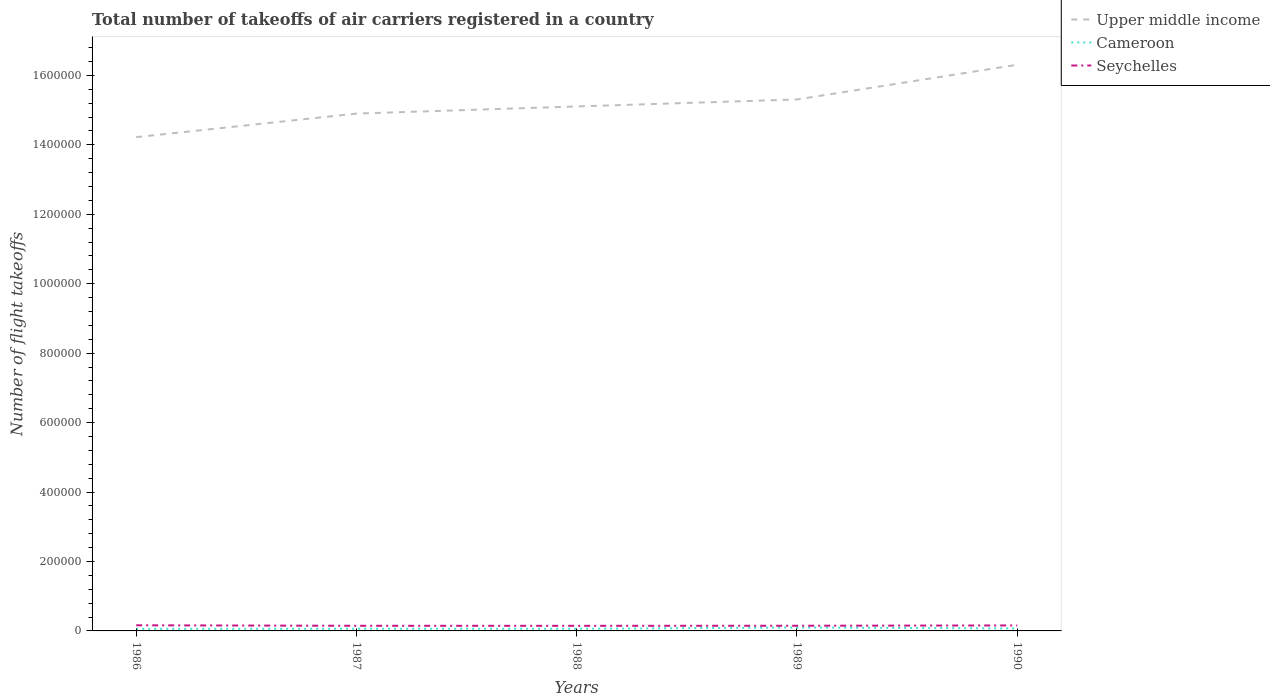How many different coloured lines are there?
Give a very brief answer. 3. Does the line corresponding to Seychelles intersect with the line corresponding to Cameroon?
Give a very brief answer. No. Across all years, what is the maximum total number of flight takeoffs in Seychelles?
Offer a terse response. 1.47e+04. In which year was the total number of flight takeoffs in Cameroon maximum?
Provide a short and direct response. 1986. What is the total total number of flight takeoffs in Upper middle income in the graph?
Provide a short and direct response. -2.06e+04. What is the difference between the highest and the second highest total number of flight takeoffs in Seychelles?
Provide a succinct answer. 1500. Is the total number of flight takeoffs in Upper middle income strictly greater than the total number of flight takeoffs in Seychelles over the years?
Ensure brevity in your answer.  No. What is the difference between two consecutive major ticks on the Y-axis?
Your answer should be very brief. 2.00e+05. Does the graph contain any zero values?
Provide a succinct answer. No. Where does the legend appear in the graph?
Offer a terse response. Top right. What is the title of the graph?
Your answer should be very brief. Total number of takeoffs of air carriers registered in a country. What is the label or title of the X-axis?
Provide a short and direct response. Years. What is the label or title of the Y-axis?
Make the answer very short. Number of flight takeoffs. What is the Number of flight takeoffs of Upper middle income in 1986?
Keep it short and to the point. 1.42e+06. What is the Number of flight takeoffs in Cameroon in 1986?
Keep it short and to the point. 6100. What is the Number of flight takeoffs of Seychelles in 1986?
Your answer should be very brief. 1.62e+04. What is the Number of flight takeoffs in Upper middle income in 1987?
Provide a succinct answer. 1.49e+06. What is the Number of flight takeoffs of Cameroon in 1987?
Give a very brief answer. 6200. What is the Number of flight takeoffs in Seychelles in 1987?
Provide a succinct answer. 1.48e+04. What is the Number of flight takeoffs in Upper middle income in 1988?
Provide a short and direct response. 1.51e+06. What is the Number of flight takeoffs in Cameroon in 1988?
Provide a short and direct response. 6200. What is the Number of flight takeoffs in Seychelles in 1988?
Your answer should be compact. 1.47e+04. What is the Number of flight takeoffs in Upper middle income in 1989?
Give a very brief answer. 1.53e+06. What is the Number of flight takeoffs of Cameroon in 1989?
Provide a short and direct response. 9700. What is the Number of flight takeoffs of Seychelles in 1989?
Ensure brevity in your answer.  1.49e+04. What is the Number of flight takeoffs in Upper middle income in 1990?
Give a very brief answer. 1.63e+06. What is the Number of flight takeoffs in Cameroon in 1990?
Give a very brief answer. 7100. What is the Number of flight takeoffs in Seychelles in 1990?
Your response must be concise. 1.58e+04. Across all years, what is the maximum Number of flight takeoffs of Upper middle income?
Your response must be concise. 1.63e+06. Across all years, what is the maximum Number of flight takeoffs in Cameroon?
Ensure brevity in your answer.  9700. Across all years, what is the maximum Number of flight takeoffs of Seychelles?
Your answer should be very brief. 1.62e+04. Across all years, what is the minimum Number of flight takeoffs of Upper middle income?
Provide a succinct answer. 1.42e+06. Across all years, what is the minimum Number of flight takeoffs of Cameroon?
Offer a terse response. 6100. Across all years, what is the minimum Number of flight takeoffs of Seychelles?
Ensure brevity in your answer.  1.47e+04. What is the total Number of flight takeoffs of Upper middle income in the graph?
Provide a short and direct response. 7.58e+06. What is the total Number of flight takeoffs in Cameroon in the graph?
Your response must be concise. 3.53e+04. What is the total Number of flight takeoffs of Seychelles in the graph?
Make the answer very short. 7.64e+04. What is the difference between the Number of flight takeoffs in Upper middle income in 1986 and that in 1987?
Keep it short and to the point. -6.78e+04. What is the difference between the Number of flight takeoffs in Cameroon in 1986 and that in 1987?
Your answer should be very brief. -100. What is the difference between the Number of flight takeoffs of Seychelles in 1986 and that in 1987?
Keep it short and to the point. 1400. What is the difference between the Number of flight takeoffs in Upper middle income in 1986 and that in 1988?
Give a very brief answer. -8.84e+04. What is the difference between the Number of flight takeoffs of Cameroon in 1986 and that in 1988?
Your response must be concise. -100. What is the difference between the Number of flight takeoffs in Seychelles in 1986 and that in 1988?
Provide a short and direct response. 1500. What is the difference between the Number of flight takeoffs of Upper middle income in 1986 and that in 1989?
Make the answer very short. -1.08e+05. What is the difference between the Number of flight takeoffs of Cameroon in 1986 and that in 1989?
Your answer should be compact. -3600. What is the difference between the Number of flight takeoffs in Seychelles in 1986 and that in 1989?
Your answer should be compact. 1300. What is the difference between the Number of flight takeoffs in Upper middle income in 1986 and that in 1990?
Offer a terse response. -2.08e+05. What is the difference between the Number of flight takeoffs of Cameroon in 1986 and that in 1990?
Keep it short and to the point. -1000. What is the difference between the Number of flight takeoffs of Upper middle income in 1987 and that in 1988?
Ensure brevity in your answer.  -2.06e+04. What is the difference between the Number of flight takeoffs of Cameroon in 1987 and that in 1988?
Your answer should be very brief. 0. What is the difference between the Number of flight takeoffs in Upper middle income in 1987 and that in 1989?
Provide a succinct answer. -4.07e+04. What is the difference between the Number of flight takeoffs of Cameroon in 1987 and that in 1989?
Make the answer very short. -3500. What is the difference between the Number of flight takeoffs of Seychelles in 1987 and that in 1989?
Your answer should be compact. -100. What is the difference between the Number of flight takeoffs in Upper middle income in 1987 and that in 1990?
Your response must be concise. -1.41e+05. What is the difference between the Number of flight takeoffs in Cameroon in 1987 and that in 1990?
Give a very brief answer. -900. What is the difference between the Number of flight takeoffs in Seychelles in 1987 and that in 1990?
Offer a terse response. -1000. What is the difference between the Number of flight takeoffs of Upper middle income in 1988 and that in 1989?
Make the answer very short. -2.01e+04. What is the difference between the Number of flight takeoffs in Cameroon in 1988 and that in 1989?
Provide a succinct answer. -3500. What is the difference between the Number of flight takeoffs of Seychelles in 1988 and that in 1989?
Keep it short and to the point. -200. What is the difference between the Number of flight takeoffs in Upper middle income in 1988 and that in 1990?
Provide a succinct answer. -1.20e+05. What is the difference between the Number of flight takeoffs in Cameroon in 1988 and that in 1990?
Offer a terse response. -900. What is the difference between the Number of flight takeoffs of Seychelles in 1988 and that in 1990?
Provide a succinct answer. -1100. What is the difference between the Number of flight takeoffs of Upper middle income in 1989 and that in 1990?
Make the answer very short. -9.99e+04. What is the difference between the Number of flight takeoffs of Cameroon in 1989 and that in 1990?
Ensure brevity in your answer.  2600. What is the difference between the Number of flight takeoffs in Seychelles in 1989 and that in 1990?
Ensure brevity in your answer.  -900. What is the difference between the Number of flight takeoffs of Upper middle income in 1986 and the Number of flight takeoffs of Cameroon in 1987?
Make the answer very short. 1.42e+06. What is the difference between the Number of flight takeoffs in Upper middle income in 1986 and the Number of flight takeoffs in Seychelles in 1987?
Your answer should be compact. 1.41e+06. What is the difference between the Number of flight takeoffs of Cameroon in 1986 and the Number of flight takeoffs of Seychelles in 1987?
Offer a terse response. -8700. What is the difference between the Number of flight takeoffs in Upper middle income in 1986 and the Number of flight takeoffs in Cameroon in 1988?
Give a very brief answer. 1.42e+06. What is the difference between the Number of flight takeoffs in Upper middle income in 1986 and the Number of flight takeoffs in Seychelles in 1988?
Keep it short and to the point. 1.41e+06. What is the difference between the Number of flight takeoffs in Cameroon in 1986 and the Number of flight takeoffs in Seychelles in 1988?
Provide a succinct answer. -8600. What is the difference between the Number of flight takeoffs in Upper middle income in 1986 and the Number of flight takeoffs in Cameroon in 1989?
Offer a very short reply. 1.41e+06. What is the difference between the Number of flight takeoffs in Upper middle income in 1986 and the Number of flight takeoffs in Seychelles in 1989?
Offer a terse response. 1.41e+06. What is the difference between the Number of flight takeoffs of Cameroon in 1986 and the Number of flight takeoffs of Seychelles in 1989?
Provide a succinct answer. -8800. What is the difference between the Number of flight takeoffs of Upper middle income in 1986 and the Number of flight takeoffs of Cameroon in 1990?
Offer a terse response. 1.42e+06. What is the difference between the Number of flight takeoffs of Upper middle income in 1986 and the Number of flight takeoffs of Seychelles in 1990?
Your response must be concise. 1.41e+06. What is the difference between the Number of flight takeoffs of Cameroon in 1986 and the Number of flight takeoffs of Seychelles in 1990?
Make the answer very short. -9700. What is the difference between the Number of flight takeoffs of Upper middle income in 1987 and the Number of flight takeoffs of Cameroon in 1988?
Provide a short and direct response. 1.48e+06. What is the difference between the Number of flight takeoffs in Upper middle income in 1987 and the Number of flight takeoffs in Seychelles in 1988?
Your response must be concise. 1.48e+06. What is the difference between the Number of flight takeoffs of Cameroon in 1987 and the Number of flight takeoffs of Seychelles in 1988?
Your answer should be very brief. -8500. What is the difference between the Number of flight takeoffs of Upper middle income in 1987 and the Number of flight takeoffs of Cameroon in 1989?
Offer a terse response. 1.48e+06. What is the difference between the Number of flight takeoffs in Upper middle income in 1987 and the Number of flight takeoffs in Seychelles in 1989?
Keep it short and to the point. 1.48e+06. What is the difference between the Number of flight takeoffs of Cameroon in 1987 and the Number of flight takeoffs of Seychelles in 1989?
Make the answer very short. -8700. What is the difference between the Number of flight takeoffs of Upper middle income in 1987 and the Number of flight takeoffs of Cameroon in 1990?
Offer a terse response. 1.48e+06. What is the difference between the Number of flight takeoffs of Upper middle income in 1987 and the Number of flight takeoffs of Seychelles in 1990?
Your answer should be very brief. 1.47e+06. What is the difference between the Number of flight takeoffs in Cameroon in 1987 and the Number of flight takeoffs in Seychelles in 1990?
Give a very brief answer. -9600. What is the difference between the Number of flight takeoffs in Upper middle income in 1988 and the Number of flight takeoffs in Cameroon in 1989?
Provide a short and direct response. 1.50e+06. What is the difference between the Number of flight takeoffs in Upper middle income in 1988 and the Number of flight takeoffs in Seychelles in 1989?
Offer a very short reply. 1.50e+06. What is the difference between the Number of flight takeoffs of Cameroon in 1988 and the Number of flight takeoffs of Seychelles in 1989?
Offer a terse response. -8700. What is the difference between the Number of flight takeoffs of Upper middle income in 1988 and the Number of flight takeoffs of Cameroon in 1990?
Make the answer very short. 1.50e+06. What is the difference between the Number of flight takeoffs in Upper middle income in 1988 and the Number of flight takeoffs in Seychelles in 1990?
Your answer should be very brief. 1.49e+06. What is the difference between the Number of flight takeoffs of Cameroon in 1988 and the Number of flight takeoffs of Seychelles in 1990?
Your answer should be very brief. -9600. What is the difference between the Number of flight takeoffs of Upper middle income in 1989 and the Number of flight takeoffs of Cameroon in 1990?
Your response must be concise. 1.52e+06. What is the difference between the Number of flight takeoffs in Upper middle income in 1989 and the Number of flight takeoffs in Seychelles in 1990?
Make the answer very short. 1.51e+06. What is the difference between the Number of flight takeoffs in Cameroon in 1989 and the Number of flight takeoffs in Seychelles in 1990?
Provide a succinct answer. -6100. What is the average Number of flight takeoffs of Upper middle income per year?
Provide a short and direct response. 1.52e+06. What is the average Number of flight takeoffs of Cameroon per year?
Make the answer very short. 7060. What is the average Number of flight takeoffs in Seychelles per year?
Give a very brief answer. 1.53e+04. In the year 1986, what is the difference between the Number of flight takeoffs in Upper middle income and Number of flight takeoffs in Cameroon?
Make the answer very short. 1.42e+06. In the year 1986, what is the difference between the Number of flight takeoffs in Upper middle income and Number of flight takeoffs in Seychelles?
Provide a succinct answer. 1.41e+06. In the year 1986, what is the difference between the Number of flight takeoffs of Cameroon and Number of flight takeoffs of Seychelles?
Your answer should be very brief. -1.01e+04. In the year 1987, what is the difference between the Number of flight takeoffs in Upper middle income and Number of flight takeoffs in Cameroon?
Provide a succinct answer. 1.48e+06. In the year 1987, what is the difference between the Number of flight takeoffs in Upper middle income and Number of flight takeoffs in Seychelles?
Your answer should be compact. 1.48e+06. In the year 1987, what is the difference between the Number of flight takeoffs in Cameroon and Number of flight takeoffs in Seychelles?
Your response must be concise. -8600. In the year 1988, what is the difference between the Number of flight takeoffs in Upper middle income and Number of flight takeoffs in Cameroon?
Your answer should be compact. 1.50e+06. In the year 1988, what is the difference between the Number of flight takeoffs of Upper middle income and Number of flight takeoffs of Seychelles?
Provide a succinct answer. 1.50e+06. In the year 1988, what is the difference between the Number of flight takeoffs of Cameroon and Number of flight takeoffs of Seychelles?
Provide a short and direct response. -8500. In the year 1989, what is the difference between the Number of flight takeoffs of Upper middle income and Number of flight takeoffs of Cameroon?
Keep it short and to the point. 1.52e+06. In the year 1989, what is the difference between the Number of flight takeoffs of Upper middle income and Number of flight takeoffs of Seychelles?
Your answer should be very brief. 1.52e+06. In the year 1989, what is the difference between the Number of flight takeoffs in Cameroon and Number of flight takeoffs in Seychelles?
Offer a very short reply. -5200. In the year 1990, what is the difference between the Number of flight takeoffs in Upper middle income and Number of flight takeoffs in Cameroon?
Provide a succinct answer. 1.62e+06. In the year 1990, what is the difference between the Number of flight takeoffs of Upper middle income and Number of flight takeoffs of Seychelles?
Your answer should be very brief. 1.61e+06. In the year 1990, what is the difference between the Number of flight takeoffs of Cameroon and Number of flight takeoffs of Seychelles?
Offer a terse response. -8700. What is the ratio of the Number of flight takeoffs of Upper middle income in 1986 to that in 1987?
Provide a short and direct response. 0.95. What is the ratio of the Number of flight takeoffs of Cameroon in 1986 to that in 1987?
Your answer should be very brief. 0.98. What is the ratio of the Number of flight takeoffs in Seychelles in 1986 to that in 1987?
Offer a terse response. 1.09. What is the ratio of the Number of flight takeoffs of Upper middle income in 1986 to that in 1988?
Keep it short and to the point. 0.94. What is the ratio of the Number of flight takeoffs of Cameroon in 1986 to that in 1988?
Keep it short and to the point. 0.98. What is the ratio of the Number of flight takeoffs in Seychelles in 1986 to that in 1988?
Give a very brief answer. 1.1. What is the ratio of the Number of flight takeoffs of Upper middle income in 1986 to that in 1989?
Offer a very short reply. 0.93. What is the ratio of the Number of flight takeoffs of Cameroon in 1986 to that in 1989?
Your answer should be very brief. 0.63. What is the ratio of the Number of flight takeoffs in Seychelles in 1986 to that in 1989?
Offer a very short reply. 1.09. What is the ratio of the Number of flight takeoffs of Upper middle income in 1986 to that in 1990?
Your answer should be compact. 0.87. What is the ratio of the Number of flight takeoffs in Cameroon in 1986 to that in 1990?
Give a very brief answer. 0.86. What is the ratio of the Number of flight takeoffs of Seychelles in 1986 to that in 1990?
Your answer should be compact. 1.03. What is the ratio of the Number of flight takeoffs of Upper middle income in 1987 to that in 1988?
Keep it short and to the point. 0.99. What is the ratio of the Number of flight takeoffs of Seychelles in 1987 to that in 1988?
Your answer should be very brief. 1.01. What is the ratio of the Number of flight takeoffs of Upper middle income in 1987 to that in 1989?
Your answer should be compact. 0.97. What is the ratio of the Number of flight takeoffs in Cameroon in 1987 to that in 1989?
Your response must be concise. 0.64. What is the ratio of the Number of flight takeoffs of Seychelles in 1987 to that in 1989?
Your answer should be very brief. 0.99. What is the ratio of the Number of flight takeoffs of Upper middle income in 1987 to that in 1990?
Give a very brief answer. 0.91. What is the ratio of the Number of flight takeoffs of Cameroon in 1987 to that in 1990?
Your response must be concise. 0.87. What is the ratio of the Number of flight takeoffs in Seychelles in 1987 to that in 1990?
Give a very brief answer. 0.94. What is the ratio of the Number of flight takeoffs in Upper middle income in 1988 to that in 1989?
Offer a very short reply. 0.99. What is the ratio of the Number of flight takeoffs in Cameroon in 1988 to that in 1989?
Your response must be concise. 0.64. What is the ratio of the Number of flight takeoffs in Seychelles in 1988 to that in 1989?
Provide a succinct answer. 0.99. What is the ratio of the Number of flight takeoffs in Upper middle income in 1988 to that in 1990?
Your answer should be compact. 0.93. What is the ratio of the Number of flight takeoffs in Cameroon in 1988 to that in 1990?
Your answer should be compact. 0.87. What is the ratio of the Number of flight takeoffs of Seychelles in 1988 to that in 1990?
Your answer should be compact. 0.93. What is the ratio of the Number of flight takeoffs in Upper middle income in 1989 to that in 1990?
Ensure brevity in your answer.  0.94. What is the ratio of the Number of flight takeoffs of Cameroon in 1989 to that in 1990?
Ensure brevity in your answer.  1.37. What is the ratio of the Number of flight takeoffs of Seychelles in 1989 to that in 1990?
Your answer should be very brief. 0.94. What is the difference between the highest and the second highest Number of flight takeoffs of Upper middle income?
Your answer should be very brief. 9.99e+04. What is the difference between the highest and the second highest Number of flight takeoffs in Cameroon?
Your answer should be very brief. 2600. What is the difference between the highest and the lowest Number of flight takeoffs in Upper middle income?
Keep it short and to the point. 2.08e+05. What is the difference between the highest and the lowest Number of flight takeoffs in Cameroon?
Your response must be concise. 3600. What is the difference between the highest and the lowest Number of flight takeoffs of Seychelles?
Keep it short and to the point. 1500. 